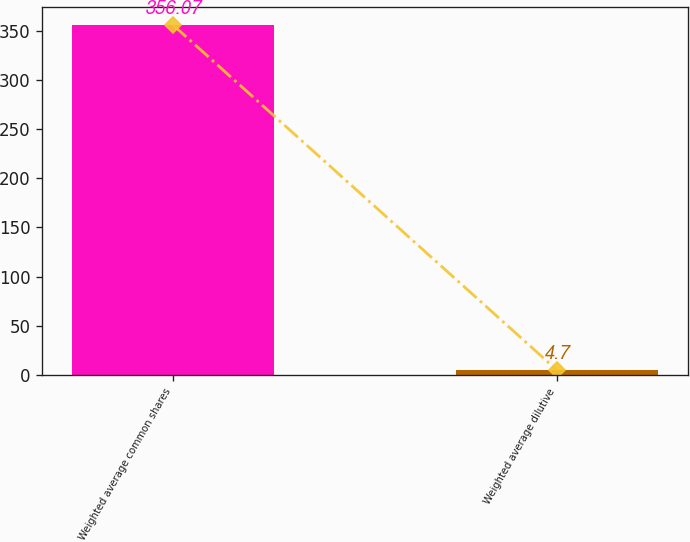Convert chart. <chart><loc_0><loc_0><loc_500><loc_500><bar_chart><fcel>Weighted average common shares<fcel>Weighted average dilutive<nl><fcel>356.07<fcel>4.7<nl></chart> 